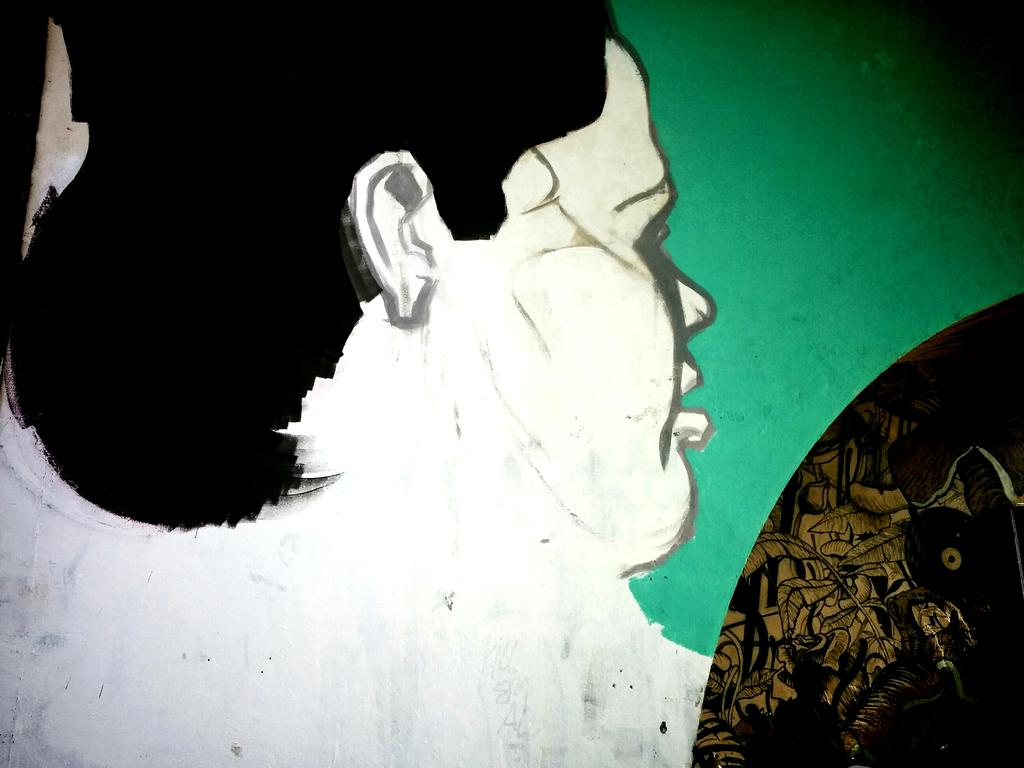What is the main subject of the image? The main subject of the image is a painting. What does the painting depict? The painting depicts a person. What type of vessel is being used by the writer in the painting? There is no vessel or writer present in the painting; it only depicts a person. What historical event is being portrayed in the painting? There is no historical event being portrayed in the painting; it only depicts a person. 